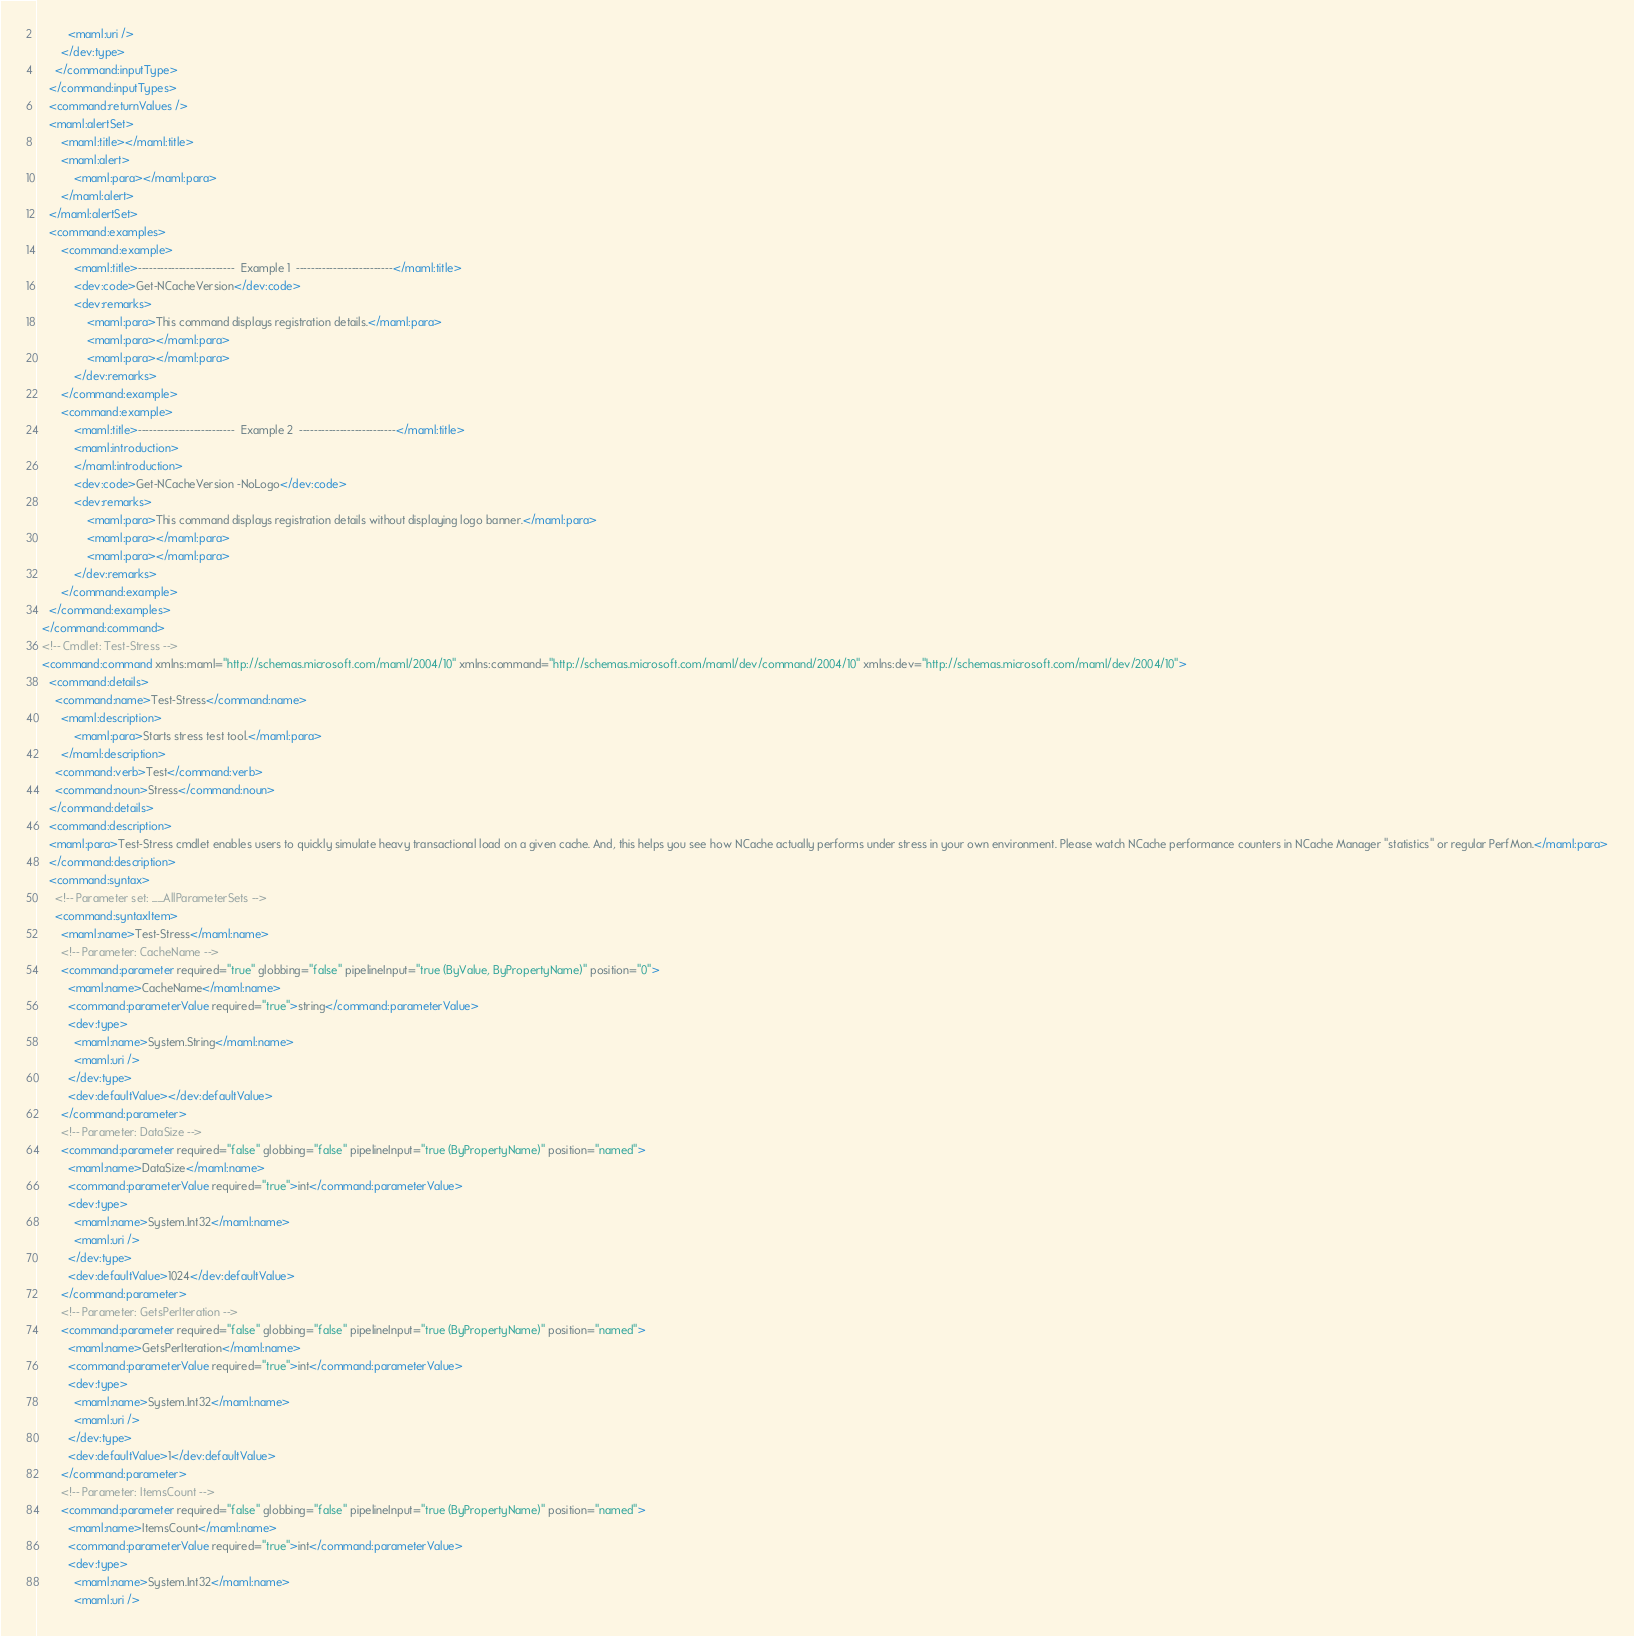Convert code to text. <code><loc_0><loc_0><loc_500><loc_500><_XML_>          <maml:uri />
        </dev:type>
      </command:inputType>
    </command:inputTypes>
    <command:returnValues />
	<maml:alertSet>
		<maml:title></maml:title>
		<maml:alert>
			<maml:para></maml:para>
		</maml:alert>
	</maml:alertSet>
	<command:examples>
		<command:example>
			<maml:title>--------------------------  Example 1  --------------------------</maml:title>
			<dev:code>Get-NCacheVersion</dev:code>
			<dev:remarks>
				<maml:para>This command displays registration details.</maml:para>
				<maml:para></maml:para>
				<maml:para></maml:para>
			</dev:remarks>
		</command:example>
		<command:example>
			<maml:title>--------------------------  Example 2  --------------------------</maml:title>
			<maml:introduction>
			</maml:introduction>
			<dev:code>Get-NCacheVersion -NoLogo</dev:code>
			<dev:remarks>
				<maml:para>This command displays registration details without displaying logo banner.</maml:para>
				<maml:para></maml:para>
				<maml:para></maml:para>
			</dev:remarks>
		</command:example>
	</command:examples>
  </command:command>
  <!-- Cmdlet: Test-Stress -->
  <command:command xmlns:maml="http://schemas.microsoft.com/maml/2004/10" xmlns:command="http://schemas.microsoft.com/maml/dev/command/2004/10" xmlns:dev="http://schemas.microsoft.com/maml/dev/2004/10">
    <command:details>
      <command:name>Test-Stress</command:name>
	    <maml:description>
			<maml:para>Starts stress test tool.</maml:para>
		</maml:description>
      <command:verb>Test</command:verb>
      <command:noun>Stress</command:noun>
    </command:details>
	<command:description>
	<maml:para>Test-Stress cmdlet enables users to quickly simulate heavy transactional load on a given cache. And, this helps you see how NCache actually performs under stress in your own environment. Please watch NCache performance counters in NCache Manager "statistics" or regular PerfMon.</maml:para>
	</command:description>
    <command:syntax>
      <!-- Parameter set: __AllParameterSets -->
      <command:syntaxItem>
        <maml:name>Test-Stress</maml:name>
        <!-- Parameter: CacheName -->
        <command:parameter required="true" globbing="false" pipelineInput="true (ByValue, ByPropertyName)" position="0">
          <maml:name>CacheName</maml:name>
          <command:parameterValue required="true">string</command:parameterValue>
          <dev:type>
            <maml:name>System.String</maml:name>
            <maml:uri />
          </dev:type>
          <dev:defaultValue></dev:defaultValue>
        </command:parameter>
        <!-- Parameter: DataSize -->
        <command:parameter required="false" globbing="false" pipelineInput="true (ByPropertyName)" position="named">
          <maml:name>DataSize</maml:name>
          <command:parameterValue required="true">int</command:parameterValue>
          <dev:type>
            <maml:name>System.Int32</maml:name>
            <maml:uri />
          </dev:type>
          <dev:defaultValue>1024</dev:defaultValue>
        </command:parameter>
        <!-- Parameter: GetsPerIteration -->
        <command:parameter required="false" globbing="false" pipelineInput="true (ByPropertyName)" position="named">
          <maml:name>GetsPerIteration</maml:name>
          <command:parameterValue required="true">int</command:parameterValue>
          <dev:type>
            <maml:name>System.Int32</maml:name>
            <maml:uri />
          </dev:type>
          <dev:defaultValue>1</dev:defaultValue>
        </command:parameter>
        <!-- Parameter: ItemsCount -->
        <command:parameter required="false" globbing="false" pipelineInput="true (ByPropertyName)" position="named">
          <maml:name>ItemsCount</maml:name>
          <command:parameterValue required="true">int</command:parameterValue>
          <dev:type>
            <maml:name>System.Int32</maml:name>
            <maml:uri /></code> 